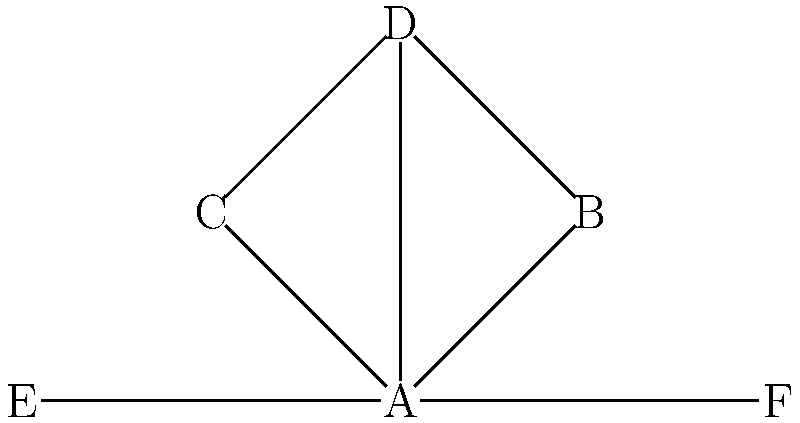In the given node-link diagram representing a network of activist organizations, what is the degree centrality of organization A? To determine the degree centrality of organization A, we need to follow these steps:

1. Understand degree centrality: It is a measure of the number of direct connections (edges) a node has to other nodes in the network.

2. Identify node A: In the diagram, node A is at the center of the network.

3. Count the connections:
   - A is connected to B
   - A is connected to C
   - A is connected to D
   - A is connected to E
   - A is connected to F

4. Sum up the connections: Node A has a total of 5 direct connections.

Therefore, the degree centrality of organization A is 5.

This high degree centrality suggests that organization A plays a central role in the network, potentially acting as a hub or coordinator among the other activist organizations.
Answer: 5 